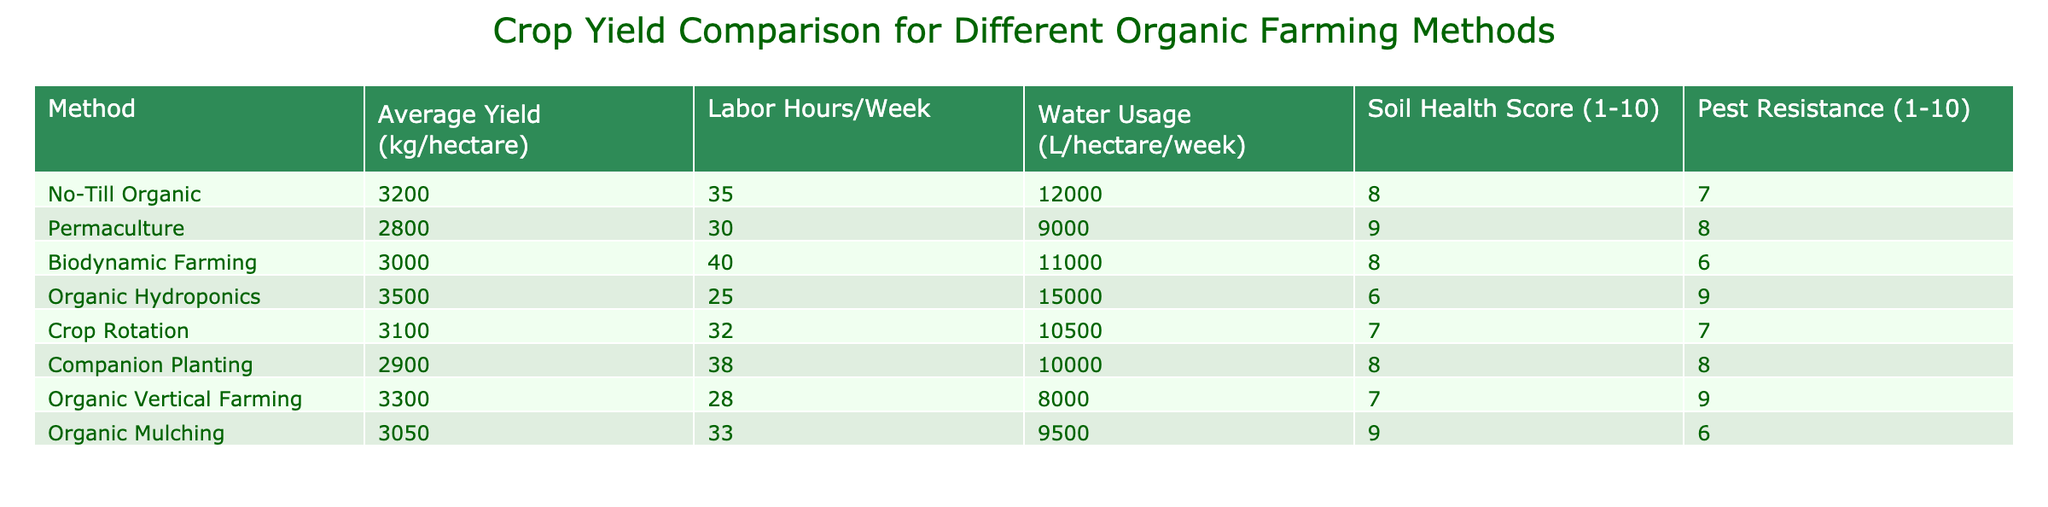What is the average yield of Organic Hydroponics? The average yield of Organic Hydroponics is given directly in the table under "Average Yield (kg/hectare)", which shows 3500 kg/hectare.
Answer: 3500 kg/hectare Which method has the highest Soil Health Score? By reviewing the "Soil Health Score (1-10)" column, Permaculture has the highest score of 9, indicating it is the best in this aspect among the methods listed.
Answer: Permaculture How much more water does Organic Hydroponics use compared to Companion Planting? The water usage for Organic Hydroponics is 15000 L/hectare/week and for Companion Planting it is 10000 L/hectare/week. The difference is 15000 - 10000 = 5000 L/hectare/week more for Organic Hydroponics.
Answer: 5000 L/hectare/week Is the Pest Resistance score of Biodynamic Farming greater than 6? The Pest Resistance score for Biodynamic Farming is listed as 6 in the table, therefore it is not greater than 6.
Answer: No Which method employs the fewest labor hours per week? Referring to the "Labor Hours/Week" column, Organic Hydroponics has the lowest labor requirement of 25 hours per week, making it the most labor-efficient method.
Answer: Organic Hydroponics What is the average Soil Health Score for the methods that have a yield above 3000 kg/hectare? The methods with yields above 3000 kg/hectare are: No-Till Organic (8), Organic Hydroponics (6), Organic Vertical Farming (7), and Crop Rotation (7). The average is (8 + 6 + 7 + 7) / 4 = 7. The average Soil Health Score is calculated as the sum divided by the count.
Answer: 7 Does No-Till Organic have a higher average yield than Crop Rotation? The average yield for No-Till Organic is 3200 kg/hectare, and for Crop Rotation, it is 3100 kg/hectare. Since 3200 is greater than 3100, No-Till Organic does have a higher average yield.
Answer: Yes What is the difference in average yield between the best and the worst performing methods? The best performing method is Organic Hydroponics with an average yield of 3500 kg/hectare, while the worst is Permaculture with an average yield of 2800 kg/hectare. The difference is 3500 - 2800 = 700 kg/hectare.
Answer: 700 kg/hectare How many methods have a Pest Resistance score of 8 or higher? The Pest Resistance scores of 8 or higher are found in the following methods: Permaculture (8), Organic Hydroponics (9), Companion Planting (8), and Organic Vertical Farming (9). That makes a total of 4 methods.
Answer: 4 